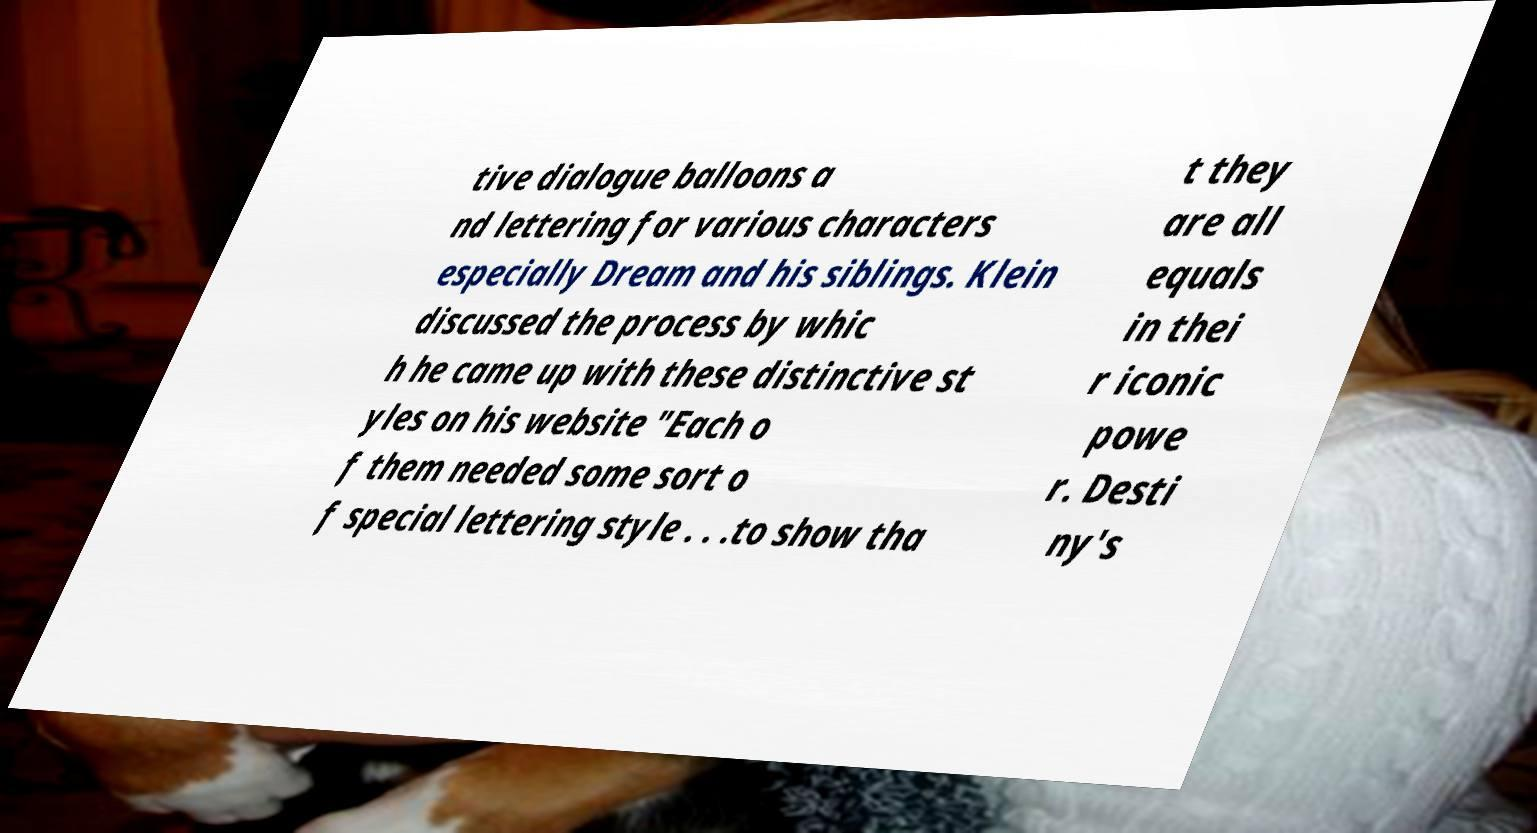Could you assist in decoding the text presented in this image and type it out clearly? tive dialogue balloons a nd lettering for various characters especially Dream and his siblings. Klein discussed the process by whic h he came up with these distinctive st yles on his website "Each o f them needed some sort o f special lettering style . . .to show tha t they are all equals in thei r iconic powe r. Desti ny's 